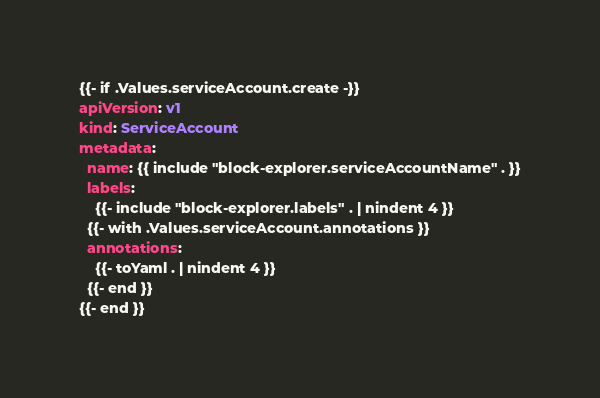Convert code to text. <code><loc_0><loc_0><loc_500><loc_500><_YAML_>{{- if .Values.serviceAccount.create -}}
apiVersion: v1
kind: ServiceAccount
metadata:
  name: {{ include "block-explorer.serviceAccountName" . }}
  labels:
    {{- include "block-explorer.labels" . | nindent 4 }}
  {{- with .Values.serviceAccount.annotations }}
  annotations:
    {{- toYaml . | nindent 4 }}
  {{- end }}
{{- end }}
</code> 